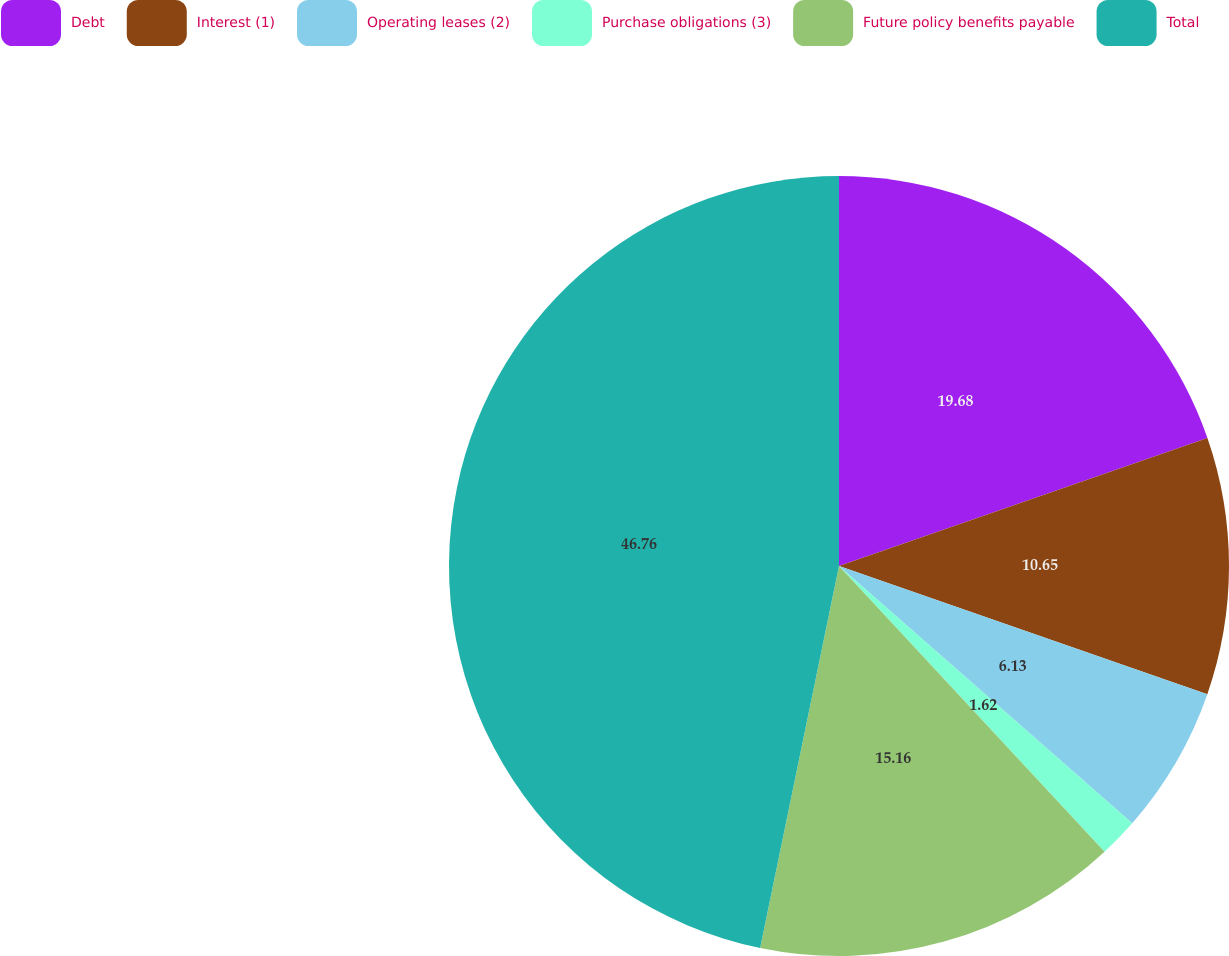Convert chart. <chart><loc_0><loc_0><loc_500><loc_500><pie_chart><fcel>Debt<fcel>Interest (1)<fcel>Operating leases (2)<fcel>Purchase obligations (3)<fcel>Future policy benefits payable<fcel>Total<nl><fcel>19.68%<fcel>10.65%<fcel>6.13%<fcel>1.62%<fcel>15.16%<fcel>46.76%<nl></chart> 